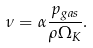<formula> <loc_0><loc_0><loc_500><loc_500>\nu = \alpha \frac { p _ { g a s } } { \rho \Omega _ { K } } .</formula> 